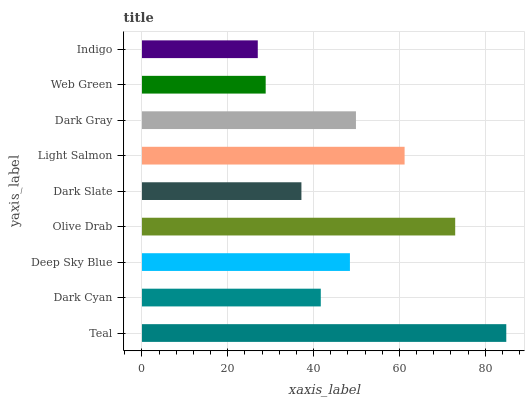Is Indigo the minimum?
Answer yes or no. Yes. Is Teal the maximum?
Answer yes or no. Yes. Is Dark Cyan the minimum?
Answer yes or no. No. Is Dark Cyan the maximum?
Answer yes or no. No. Is Teal greater than Dark Cyan?
Answer yes or no. Yes. Is Dark Cyan less than Teal?
Answer yes or no. Yes. Is Dark Cyan greater than Teal?
Answer yes or no. No. Is Teal less than Dark Cyan?
Answer yes or no. No. Is Deep Sky Blue the high median?
Answer yes or no. Yes. Is Deep Sky Blue the low median?
Answer yes or no. Yes. Is Light Salmon the high median?
Answer yes or no. No. Is Dark Cyan the low median?
Answer yes or no. No. 